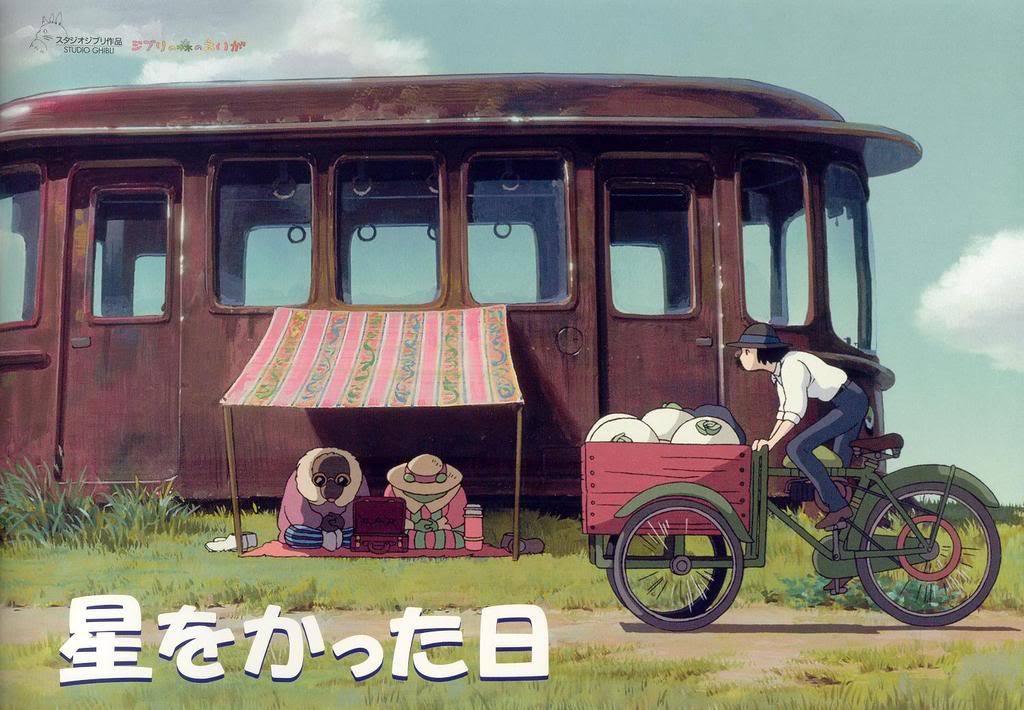Could you give a brief overview of what you see in this image? In this animated image, where we can see, grassland, people, vehicles and the sky. 